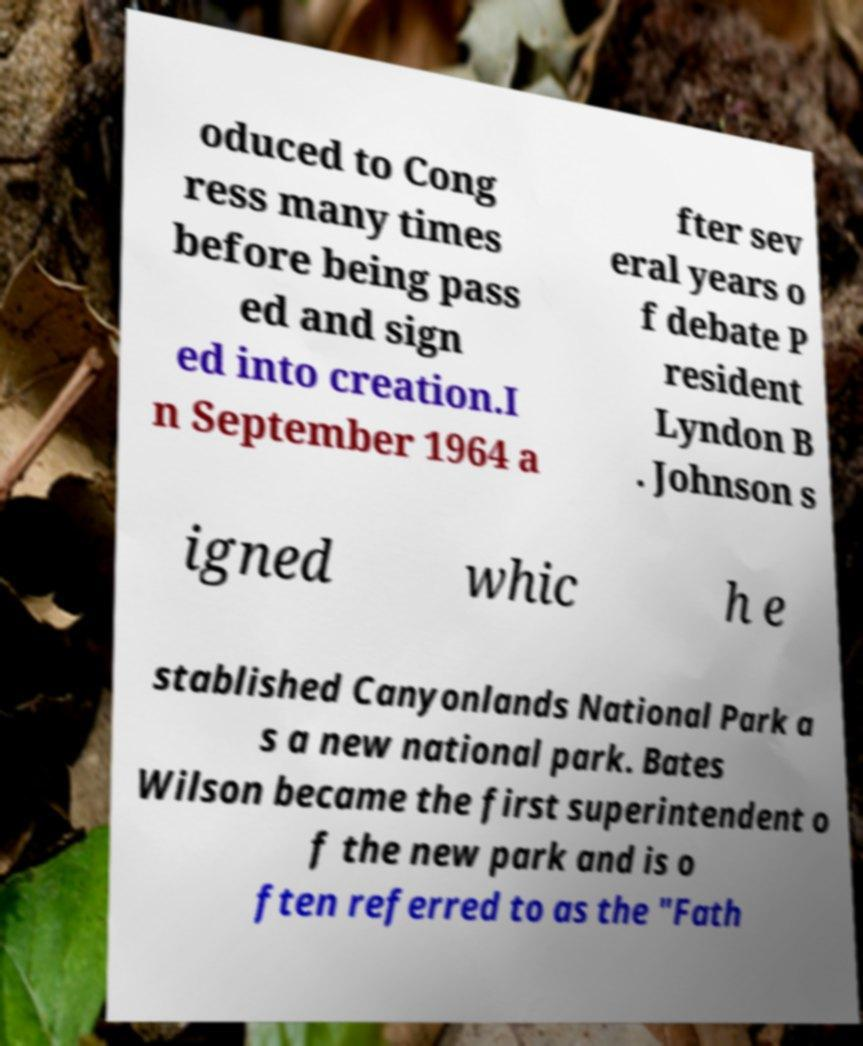What messages or text are displayed in this image? I need them in a readable, typed format. oduced to Cong ress many times before being pass ed and sign ed into creation.I n September 1964 a fter sev eral years o f debate P resident Lyndon B . Johnson s igned whic h e stablished Canyonlands National Park a s a new national park. Bates Wilson became the first superintendent o f the new park and is o ften referred to as the "Fath 